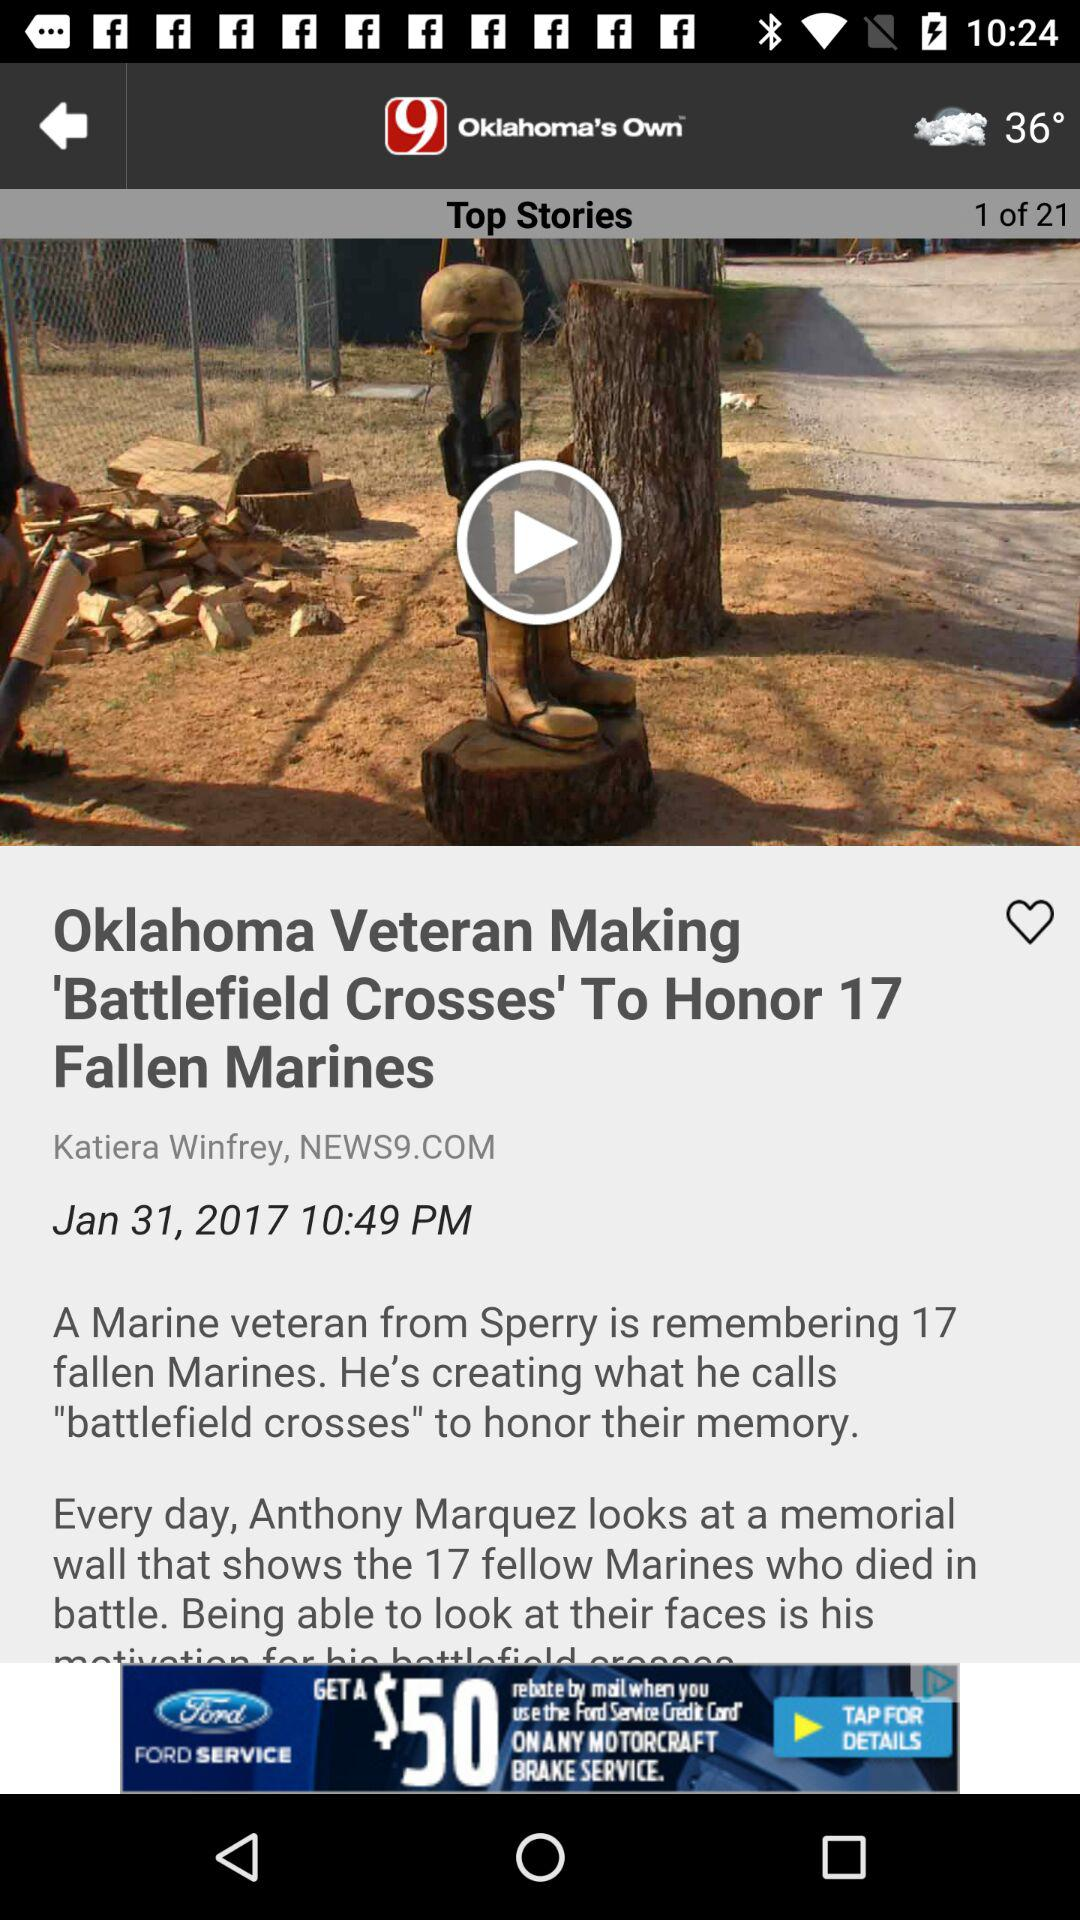How many top stories are there in total? There are 21 top stories. 